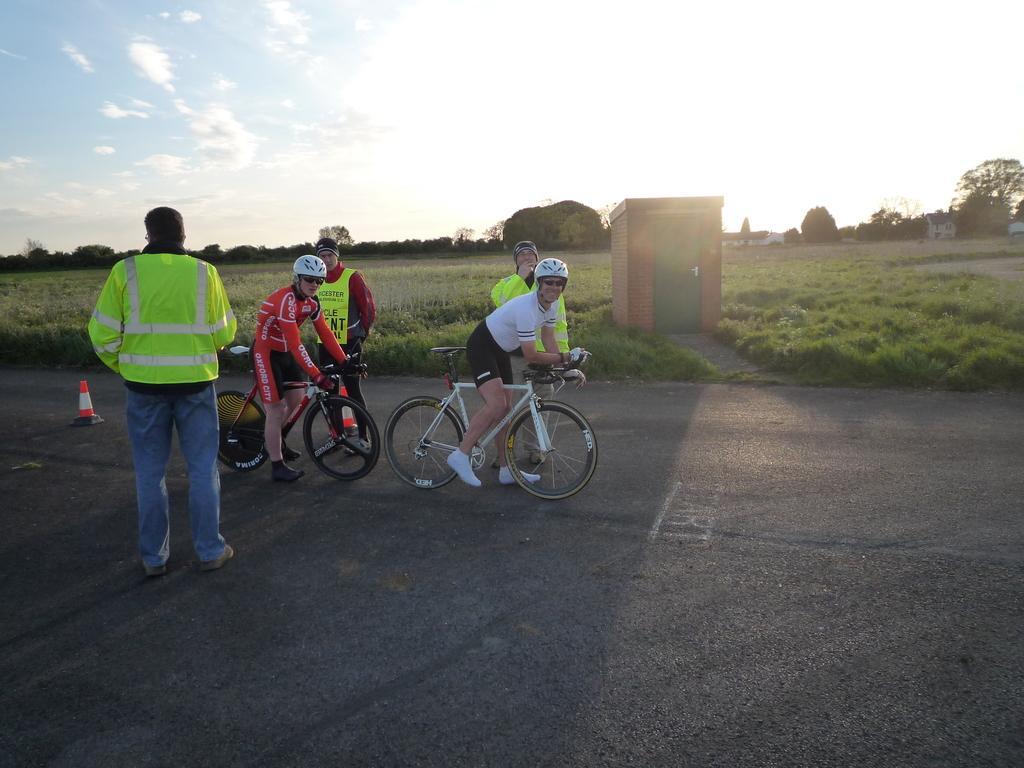Please provide a concise description of this image. In this image in the center there are three persons who are sitting on a cycle, and they are wearing helmets and in the background there are two persons and in the foreground there is another person. At the bottom there is a road, in the background there is grass and some trees and one house. On the top of the image there is sky. 